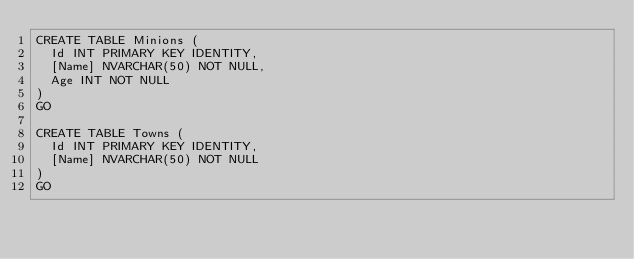Convert code to text. <code><loc_0><loc_0><loc_500><loc_500><_SQL_>CREATE TABLE Minions (
	Id INT PRIMARY KEY IDENTITY,
	[Name] NVARCHAR(50) NOT NULL,
	Age INT NOT NULL
)
GO

CREATE TABLE Towns (
	Id INT PRIMARY KEY IDENTITY,
	[Name] NVARCHAR(50) NOT NULL
)
GO</code> 